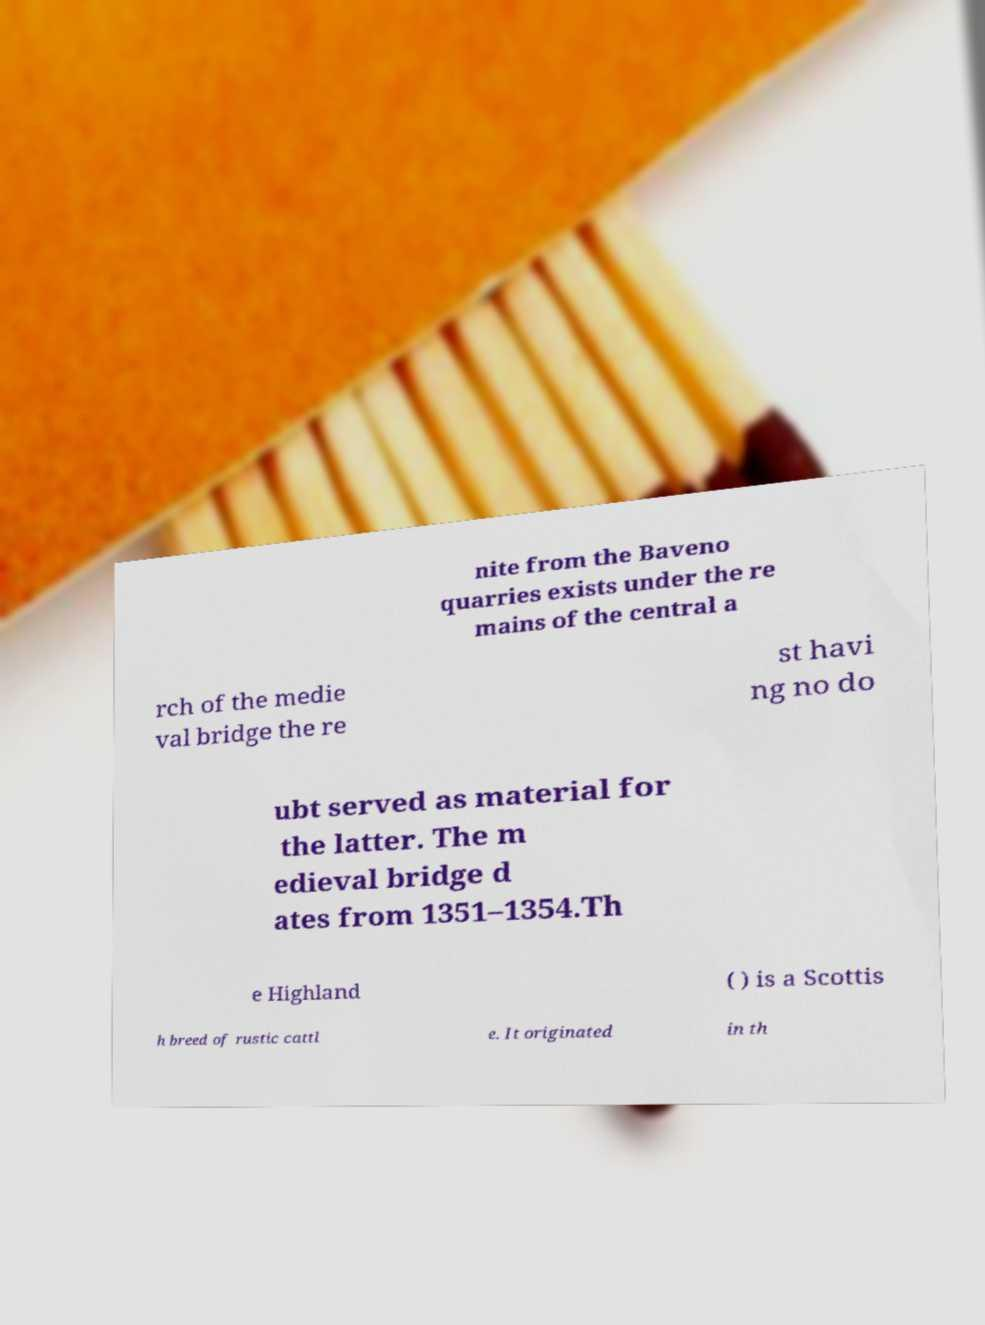Please read and relay the text visible in this image. What does it say? nite from the Baveno quarries exists under the re mains of the central a rch of the medie val bridge the re st havi ng no do ubt served as material for the latter. The m edieval bridge d ates from 1351–1354.Th e Highland ( ) is a Scottis h breed of rustic cattl e. It originated in th 